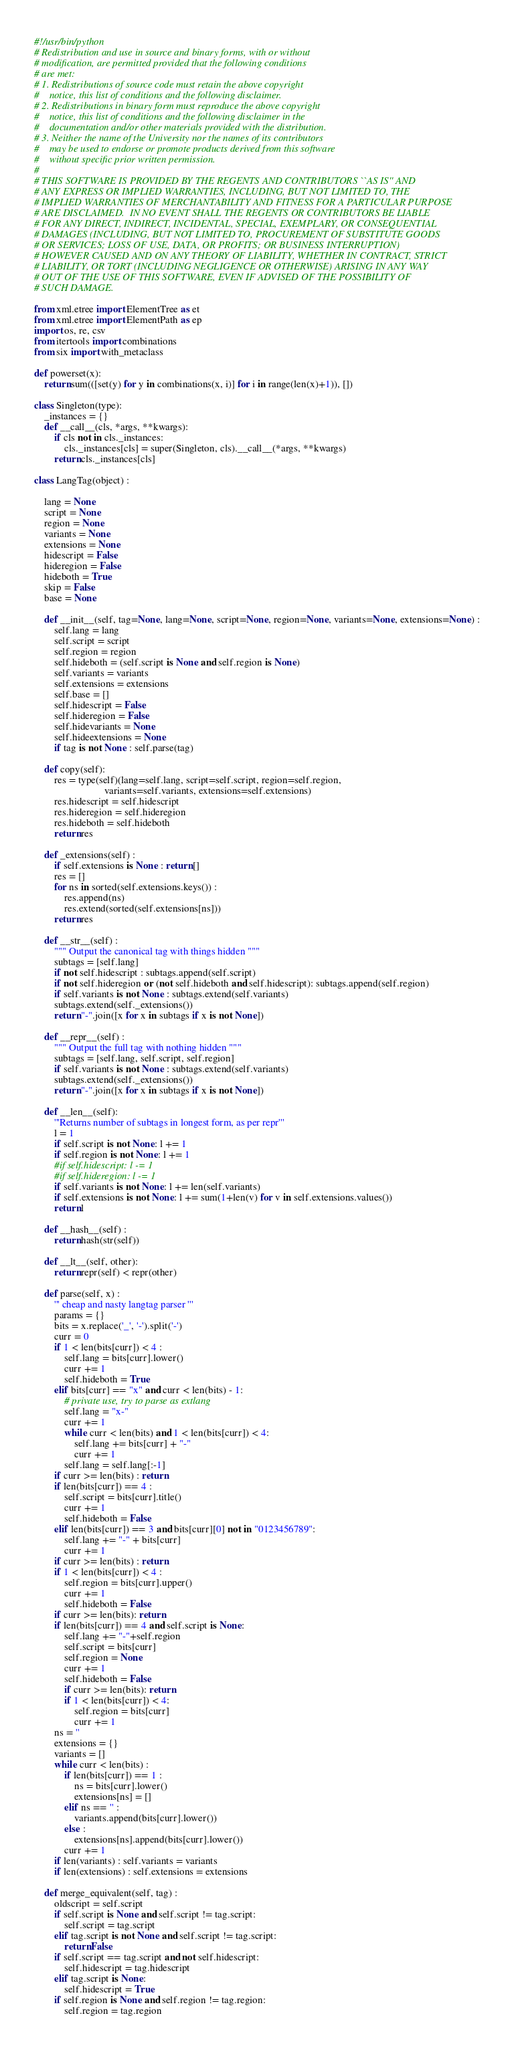Convert code to text. <code><loc_0><loc_0><loc_500><loc_500><_Python_>#!/usr/bin/python
# Redistribution and use in source and binary forms, with or without
# modification, are permitted provided that the following conditions
# are met:
# 1. Redistributions of source code must retain the above copyright
#    notice, this list of conditions and the following disclaimer.
# 2. Redistributions in binary form must reproduce the above copyright
#    notice, this list of conditions and the following disclaimer in the
#    documentation and/or other materials provided with the distribution.
# 3. Neither the name of the University nor the names of its contributors
#    may be used to endorse or promote products derived from this software
#    without specific prior written permission.
# 
# THIS SOFTWARE IS PROVIDED BY THE REGENTS AND CONTRIBUTORS ``AS IS'' AND
# ANY EXPRESS OR IMPLIED WARRANTIES, INCLUDING, BUT NOT LIMITED TO, THE
# IMPLIED WARRANTIES OF MERCHANTABILITY AND FITNESS FOR A PARTICULAR PURPOSE
# ARE DISCLAIMED.  IN NO EVENT SHALL THE REGENTS OR CONTRIBUTORS BE LIABLE
# FOR ANY DIRECT, INDIRECT, INCIDENTAL, SPECIAL, EXEMPLARY, OR CONSEQUENTIAL
# DAMAGES (INCLUDING, BUT NOT LIMITED TO, PROCUREMENT OF SUBSTITUTE GOODS
# OR SERVICES; LOSS OF USE, DATA, OR PROFITS; OR BUSINESS INTERRUPTION)
# HOWEVER CAUSED AND ON ANY THEORY OF LIABILITY, WHETHER IN CONTRACT, STRICT
# LIABILITY, OR TORT (INCLUDING NEGLIGENCE OR OTHERWISE) ARISING IN ANY WAY
# OUT OF THE USE OF THIS SOFTWARE, EVEN IF ADVISED OF THE POSSIBILITY OF
# SUCH DAMAGE.

from xml.etree import ElementTree as et
from xml.etree import ElementPath as ep
import os, re, csv
from itertools import combinations
from six import with_metaclass

def powerset(x):
    return sum(([set(y) for y in combinations(x, i)] for i in range(len(x)+1)), [])

class Singleton(type):
    _instances = {}
    def __call__(cls, *args, **kwargs):
        if cls not in cls._instances:
            cls._instances[cls] = super(Singleton, cls).__call__(*args, **kwargs)
        return cls._instances[cls]

class LangTag(object) :

    lang = None
    script = None
    region = None
    variants = None
    extensions = None
    hidescript = False
    hideregion = False
    hideboth = True
    skip = False
    base = None

    def __init__(self, tag=None, lang=None, script=None, region=None, variants=None, extensions=None) :
        self.lang = lang
        self.script = script
        self.region = region
        self.hideboth = (self.script is None and self.region is None)
        self.variants = variants
        self.extensions = extensions
        self.base = []
        self.hidescript = False
        self.hideregion = False
        self.hidevariants = None
        self.hideextensions = None
        if tag is not None : self.parse(tag)

    def copy(self):
        res = type(self)(lang=self.lang, script=self.script, region=self.region,
                            variants=self.variants, extensions=self.extensions)
        res.hidescript = self.hidescript
        res.hideregion = self.hideregion
        res.hideboth = self.hideboth
        return res

    def _extensions(self) :
        if self.extensions is None : return []
        res = []
        for ns in sorted(self.extensions.keys()) :
            res.append(ns)
            res.extend(sorted(self.extensions[ns]))
        return res

    def __str__(self) :
        """ Output the canonical tag with things hidden """
        subtags = [self.lang]
        if not self.hidescript : subtags.append(self.script)
        if not self.hideregion or (not self.hideboth and self.hidescript): subtags.append(self.region)
        if self.variants is not None : subtags.extend(self.variants)
        subtags.extend(self._extensions())
        return "-".join([x for x in subtags if x is not None])

    def __repr__(self) :
        """ Output the full tag with nothing hidden """
        subtags = [self.lang, self.script, self.region]
        if self.variants is not None : subtags.extend(self.variants)
        subtags.extend(self._extensions())
        return "-".join([x for x in subtags if x is not None])

    def __len__(self):
        '''Returns number of subtags in longest form, as per repr'''
        l = 1
        if self.script is not None: l += 1
        if self.region is not None: l += 1
        #if self.hidescript: l -= 1
        #if self.hideregion: l -= 1
        if self.variants is not None: l += len(self.variants)
        if self.extensions is not None: l += sum(1+len(v) for v in self.extensions.values())
        return l

    def __hash__(self) :
        return hash(str(self))

    def __lt__(self, other):
        return repr(self) < repr(other)

    def parse(self, x) :
        ''' cheap and nasty langtag parser '''
        params = {}
        bits = x.replace('_', '-').split('-')
        curr = 0
        if 1 < len(bits[curr]) < 4 :
            self.lang = bits[curr].lower()
            curr += 1
            self.hideboth = True
        elif bits[curr] == "x" and curr < len(bits) - 1:
            # private use, try to parse as extlang
            self.lang = "x-"
            curr += 1
            while curr < len(bits) and 1 < len(bits[curr]) < 4:
                self.lang += bits[curr] + "-"
                curr += 1
            self.lang = self.lang[:-1]
        if curr >= len(bits) : return
        if len(bits[curr]) == 4 :
            self.script = bits[curr].title()
            curr += 1
            self.hideboth = False
        elif len(bits[curr]) == 3 and bits[curr][0] not in "0123456789":
            self.lang += "-" + bits[curr]
            curr += 1
        if curr >= len(bits) : return
        if 1 < len(bits[curr]) < 4 :
            self.region = bits[curr].upper()
            curr += 1
            self.hideboth = False
        if curr >= len(bits): return
        if len(bits[curr]) == 4 and self.script is None:
            self.lang += "-"+self.region
            self.script = bits[curr]
            self.region = None
            curr += 1
            self.hideboth = False
            if curr >= len(bits): return
            if 1 < len(bits[curr]) < 4:
                self.region = bits[curr]
                curr += 1
        ns = ''
        extensions = {}
        variants = []
        while curr < len(bits) :
            if len(bits[curr]) == 1 :
                ns = bits[curr].lower()
                extensions[ns] = []
            elif ns == '' :
                variants.append(bits[curr].lower())
            else :
                extensions[ns].append(bits[curr].lower())
            curr += 1
        if len(variants) : self.variants = variants
        if len(extensions) : self.extensions = extensions

    def merge_equivalent(self, tag) :
        oldscript = self.script
        if self.script is None and self.script != tag.script:
            self.script = tag.script
        elif tag.script is not None and self.script != tag.script:
            return False
        if self.script == tag.script and not self.hidescript:
            self.hidescript = tag.hidescript
        elif tag.script is None:
            self.hidescript = True
        if self.region is None and self.region != tag.region:
            self.region = tag.region</code> 